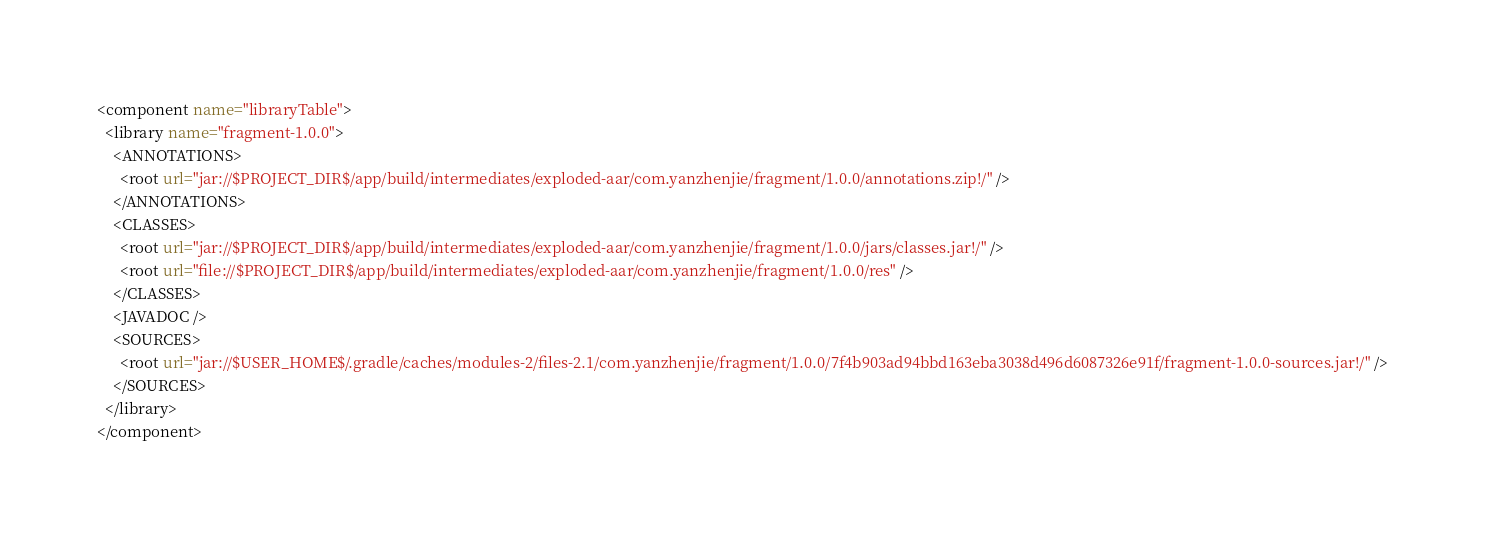<code> <loc_0><loc_0><loc_500><loc_500><_XML_><component name="libraryTable">
  <library name="fragment-1.0.0">
    <ANNOTATIONS>
      <root url="jar://$PROJECT_DIR$/app/build/intermediates/exploded-aar/com.yanzhenjie/fragment/1.0.0/annotations.zip!/" />
    </ANNOTATIONS>
    <CLASSES>
      <root url="jar://$PROJECT_DIR$/app/build/intermediates/exploded-aar/com.yanzhenjie/fragment/1.0.0/jars/classes.jar!/" />
      <root url="file://$PROJECT_DIR$/app/build/intermediates/exploded-aar/com.yanzhenjie/fragment/1.0.0/res" />
    </CLASSES>
    <JAVADOC />
    <SOURCES>
      <root url="jar://$USER_HOME$/.gradle/caches/modules-2/files-2.1/com.yanzhenjie/fragment/1.0.0/7f4b903ad94bbd163eba3038d496d6087326e91f/fragment-1.0.0-sources.jar!/" />
    </SOURCES>
  </library>
</component></code> 